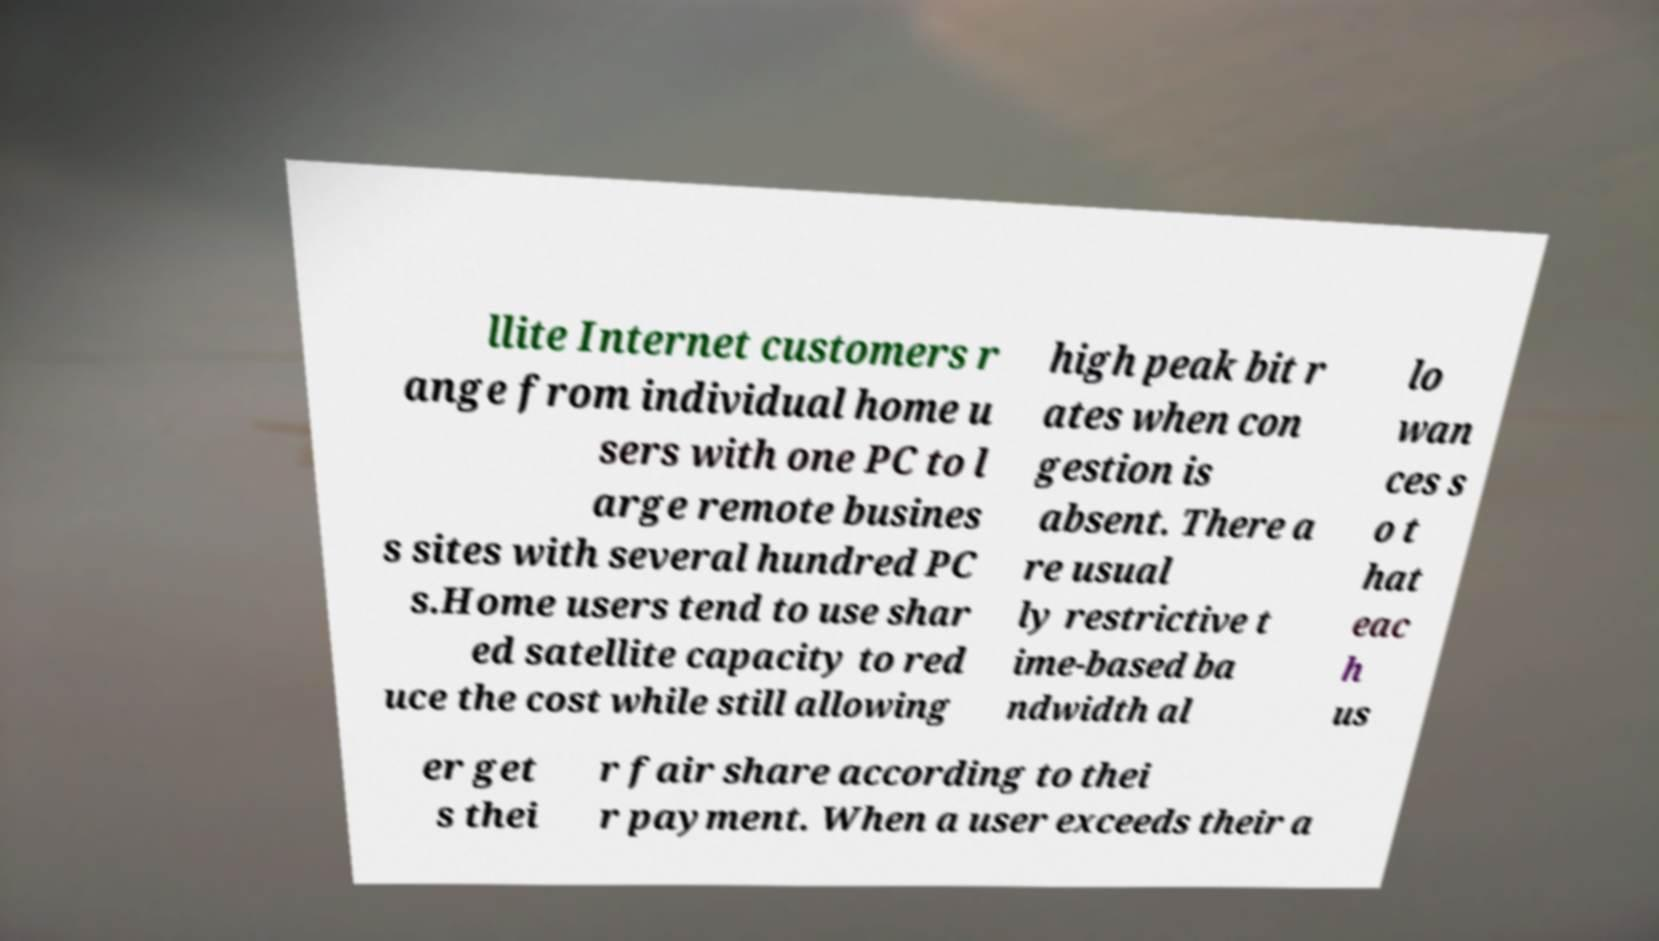I need the written content from this picture converted into text. Can you do that? llite Internet customers r ange from individual home u sers with one PC to l arge remote busines s sites with several hundred PC s.Home users tend to use shar ed satellite capacity to red uce the cost while still allowing high peak bit r ates when con gestion is absent. There a re usual ly restrictive t ime-based ba ndwidth al lo wan ces s o t hat eac h us er get s thei r fair share according to thei r payment. When a user exceeds their a 